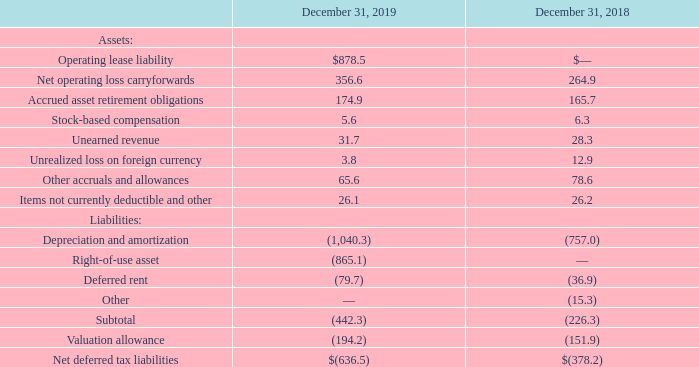AMERICAN TOWER CORPORATION AND SUBSIDIARIES NOTES TO CONSOLIDATED FINANCIAL STATEMENTS (Tabular amounts in millions, unless otherwise disclosed)
The components of the net deferred tax asset and liability and related valuation allowance were as follows:
The Company provides valuation allowances if, based on the available evidence, it is more likely than not that some or all of the deferred tax assets will not be realized. Management assesses the available evidence to estimate if sufficient future taxable income will be generated to use the existing deferred tax assets.
When does the company provide valuation allowances? If, based on the available evidence, it is more likely than not that some or all of the deferred tax assets will not be realized. What were the Net operating loss carryforwards in 2019?
Answer scale should be: million. 356.6. What was the Stock-based compensation in 2018?
Answer scale should be: million. 6.3. How many components of assets in 2018 were above $100 million? Net operating loss carryforwards##Accrued asset retirement obligations
Answer: 2. How many components of assets in 2019 were above $50 million?  Operating lease liability ##Net operating loss carryforwards##Accrued asset retirement obligations##Other accruals and allowances
Answer: 4. What was the percentage change in Net deferred tax liabilities between 2018 and 2019?
Answer scale should be: percent. (-636.5-(-378.2))/-378.2
Answer: 68.3. 